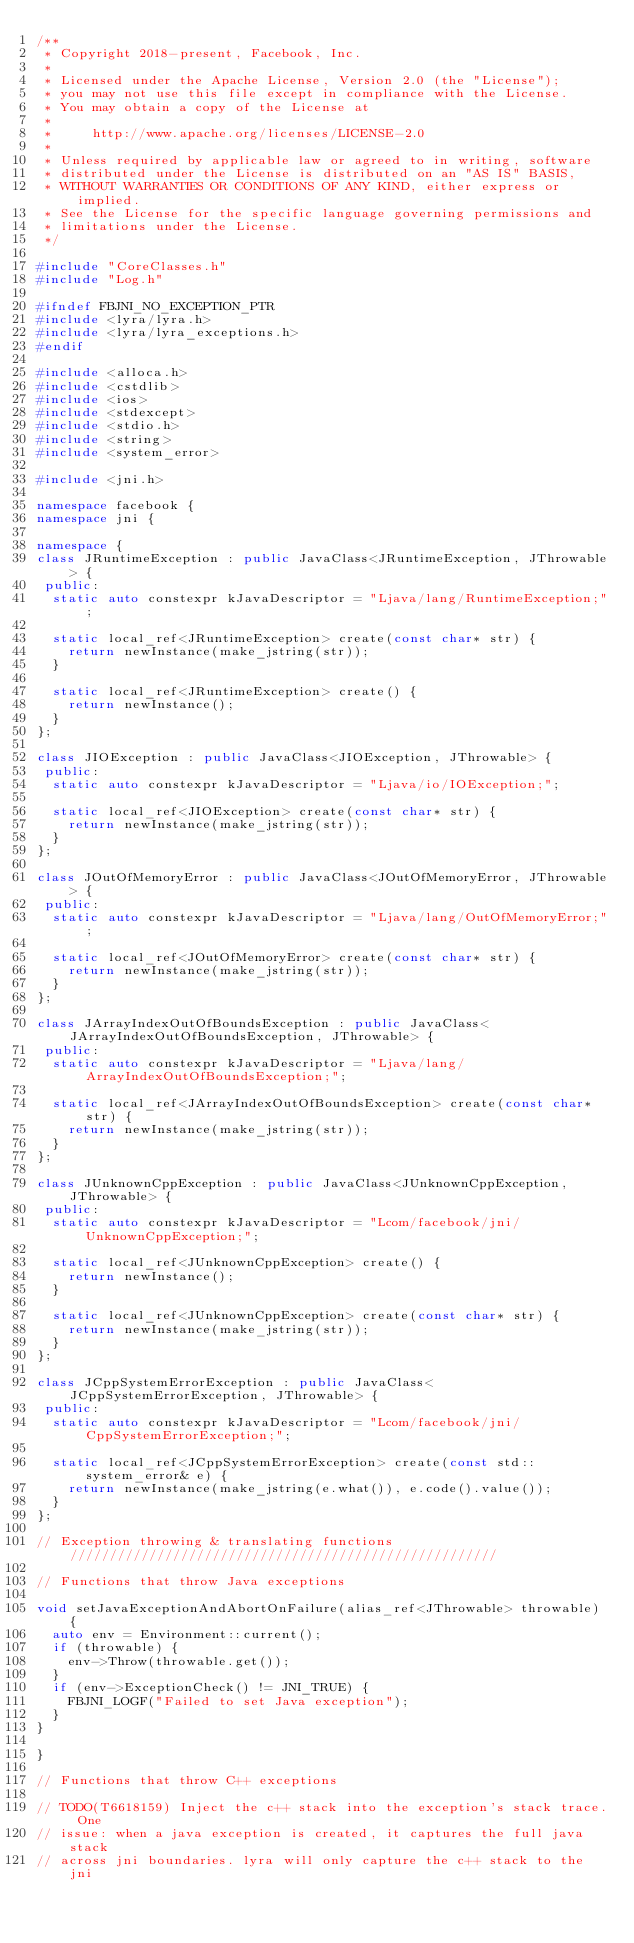<code> <loc_0><loc_0><loc_500><loc_500><_C++_>/**
 * Copyright 2018-present, Facebook, Inc.
 *
 * Licensed under the Apache License, Version 2.0 (the "License");
 * you may not use this file except in compliance with the License.
 * You may obtain a copy of the License at
 *
 *     http://www.apache.org/licenses/LICENSE-2.0
 *
 * Unless required by applicable law or agreed to in writing, software
 * distributed under the License is distributed on an "AS IS" BASIS,
 * WITHOUT WARRANTIES OR CONDITIONS OF ANY KIND, either express or implied.
 * See the License for the specific language governing permissions and
 * limitations under the License.
 */

#include "CoreClasses.h"
#include "Log.h"

#ifndef FBJNI_NO_EXCEPTION_PTR
#include <lyra/lyra.h>
#include <lyra/lyra_exceptions.h>
#endif

#include <alloca.h>
#include <cstdlib>
#include <ios>
#include <stdexcept>
#include <stdio.h>
#include <string>
#include <system_error>

#include <jni.h>

namespace facebook {
namespace jni {

namespace {
class JRuntimeException : public JavaClass<JRuntimeException, JThrowable> {
 public:
  static auto constexpr kJavaDescriptor = "Ljava/lang/RuntimeException;";

  static local_ref<JRuntimeException> create(const char* str) {
    return newInstance(make_jstring(str));
  }

  static local_ref<JRuntimeException> create() {
    return newInstance();
  }
};

class JIOException : public JavaClass<JIOException, JThrowable> {
 public:
  static auto constexpr kJavaDescriptor = "Ljava/io/IOException;";

  static local_ref<JIOException> create(const char* str) {
    return newInstance(make_jstring(str));
  }
};

class JOutOfMemoryError : public JavaClass<JOutOfMemoryError, JThrowable> {
 public:
  static auto constexpr kJavaDescriptor = "Ljava/lang/OutOfMemoryError;";

  static local_ref<JOutOfMemoryError> create(const char* str) {
    return newInstance(make_jstring(str));
  }
};

class JArrayIndexOutOfBoundsException : public JavaClass<JArrayIndexOutOfBoundsException, JThrowable> {
 public:
  static auto constexpr kJavaDescriptor = "Ljava/lang/ArrayIndexOutOfBoundsException;";

  static local_ref<JArrayIndexOutOfBoundsException> create(const char* str) {
    return newInstance(make_jstring(str));
  }
};

class JUnknownCppException : public JavaClass<JUnknownCppException, JThrowable> {
 public:
  static auto constexpr kJavaDescriptor = "Lcom/facebook/jni/UnknownCppException;";

  static local_ref<JUnknownCppException> create() {
    return newInstance();
  }

  static local_ref<JUnknownCppException> create(const char* str) {
    return newInstance(make_jstring(str));
  }
};

class JCppSystemErrorException : public JavaClass<JCppSystemErrorException, JThrowable> {
 public:
  static auto constexpr kJavaDescriptor = "Lcom/facebook/jni/CppSystemErrorException;";

  static local_ref<JCppSystemErrorException> create(const std::system_error& e) {
    return newInstance(make_jstring(e.what()), e.code().value());
  }
};

// Exception throwing & translating functions //////////////////////////////////////////////////////

// Functions that throw Java exceptions

void setJavaExceptionAndAbortOnFailure(alias_ref<JThrowable> throwable) {
  auto env = Environment::current();
  if (throwable) {
    env->Throw(throwable.get());
  }
  if (env->ExceptionCheck() != JNI_TRUE) {
    FBJNI_LOGF("Failed to set Java exception");
  }
}

}

// Functions that throw C++ exceptions

// TODO(T6618159) Inject the c++ stack into the exception's stack trace. One
// issue: when a java exception is created, it captures the full java stack
// across jni boundaries. lyra will only capture the c++ stack to the jni</code> 